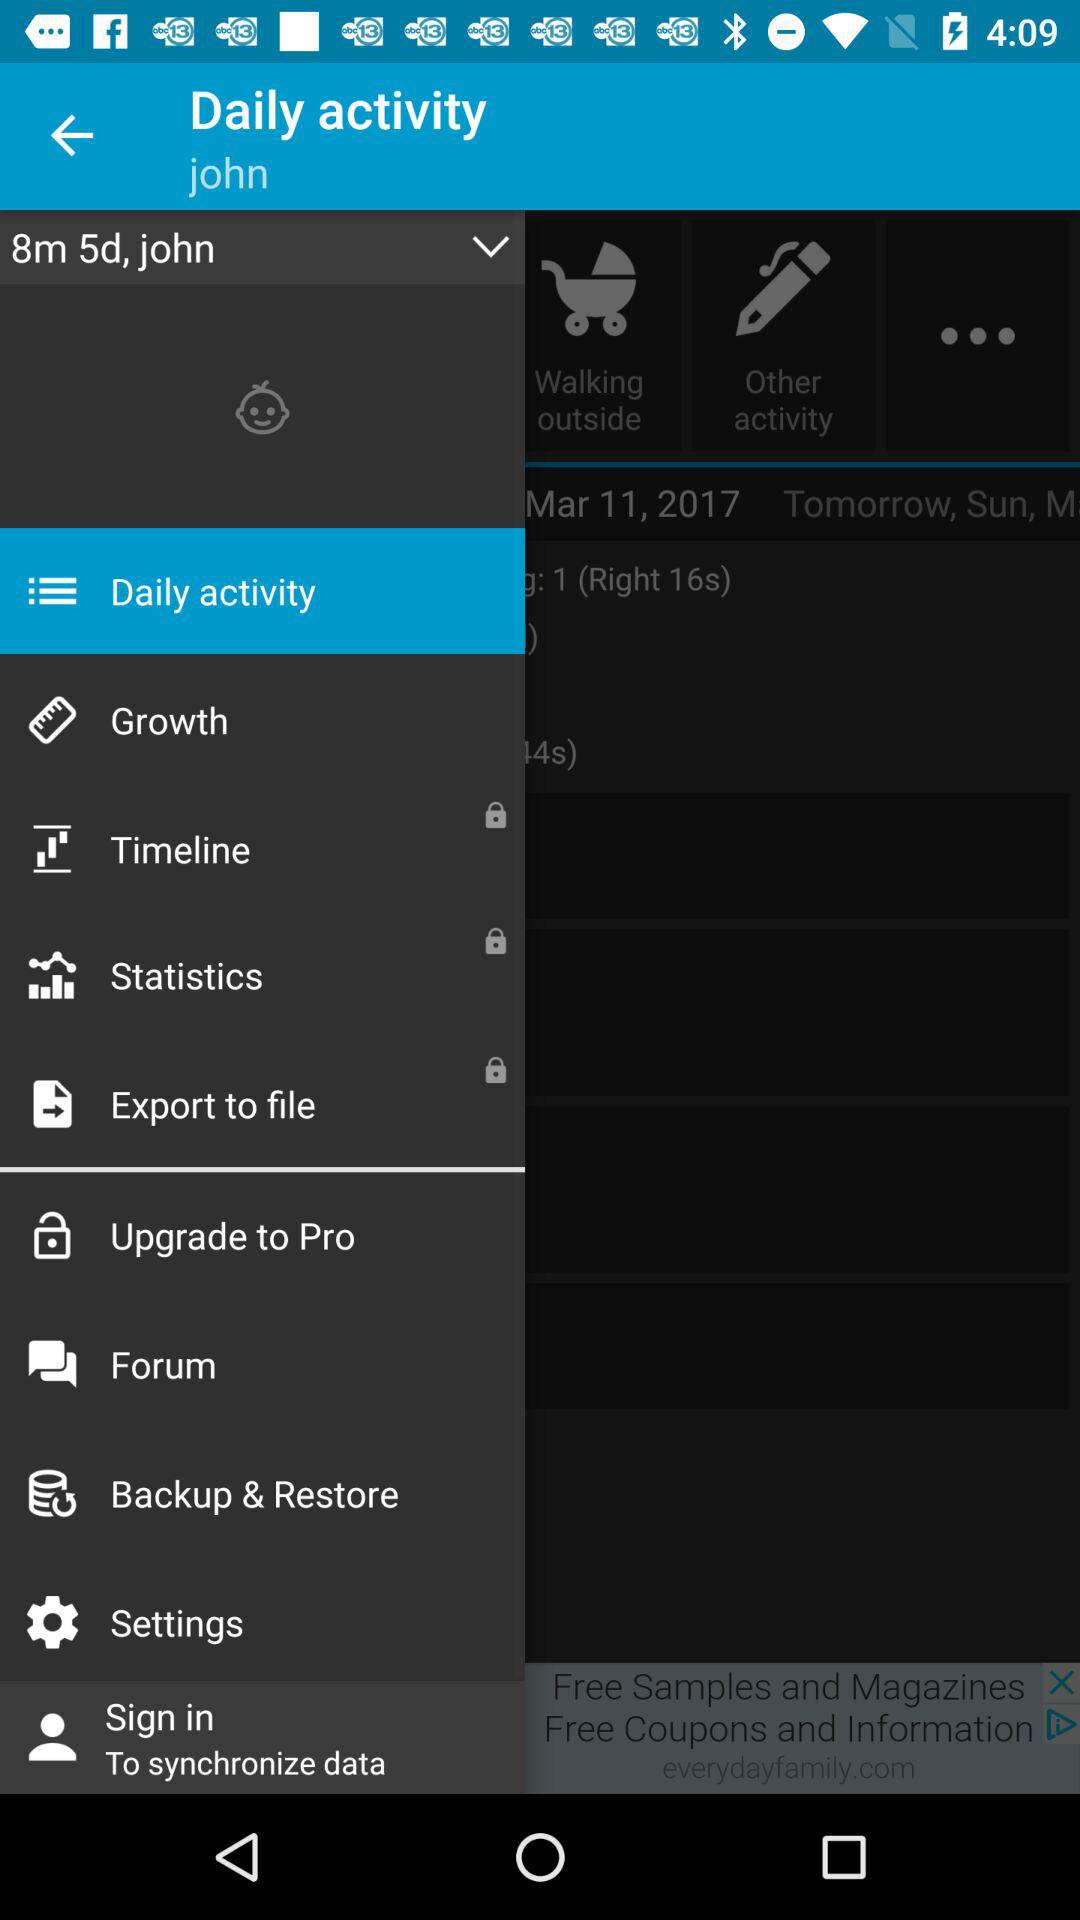What is the user name? The user name is John. 